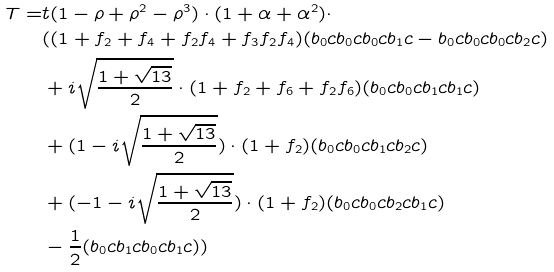Convert formula to latex. <formula><loc_0><loc_0><loc_500><loc_500>T = & t ( 1 - \rho + \rho ^ { 2 } - \rho ^ { 3 } ) \cdot ( 1 + \alpha + \alpha ^ { 2 } ) \cdot \\ & ( ( 1 + f _ { 2 } + f _ { 4 } + f _ { 2 } f _ { 4 } + f _ { 3 } f _ { 2 } f _ { 4 } ) ( b _ { 0 } c b _ { 0 } c b _ { 0 } c b _ { 1 } c - b _ { 0 } c b _ { 0 } c b _ { 0 } c b _ { 2 } c ) \\ & + i \sqrt { \frac { 1 + \sqrt { 1 3 } } { 2 } } \cdot ( 1 + f _ { 2 } + f _ { 6 } + f _ { 2 } f _ { 6 } ) ( b _ { 0 } c b _ { 0 } c b _ { 1 } c b _ { 1 } c ) \\ & + ( 1 - i \sqrt { \frac { 1 + \sqrt { 1 3 } } { 2 } } ) \cdot ( 1 + f _ { 2 } ) ( b _ { 0 } c b _ { 0 } c b _ { 1 } c b _ { 2 } c ) \\ & + ( - 1 - i \sqrt { \frac { 1 + \sqrt { 1 3 } } { 2 } } ) \cdot ( 1 + f _ { 2 } ) ( b _ { 0 } c b _ { 0 } c b _ { 2 } c b _ { 1 } c ) \\ & - \frac { 1 } { 2 } ( b _ { 0 } c b _ { 1 } c b _ { 0 } c b _ { 1 } c ) ) \\</formula> 